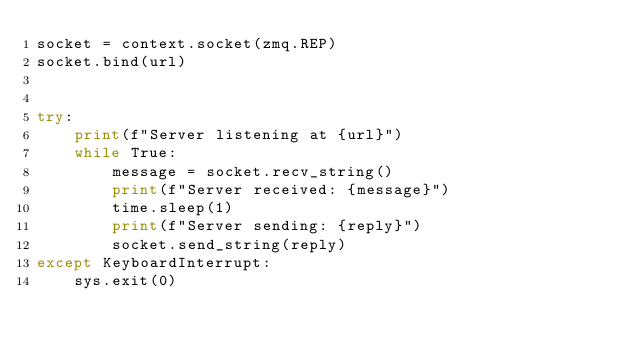Convert code to text. <code><loc_0><loc_0><loc_500><loc_500><_Python_>socket = context.socket(zmq.REP)
socket.bind(url)


try:
    print(f"Server listening at {url}")
    while True:
        message = socket.recv_string()
        print(f"Server received: {message}")
        time.sleep(1)
        print(f"Server sending: {reply}")
        socket.send_string(reply)
except KeyboardInterrupt:
    sys.exit(0)
</code> 